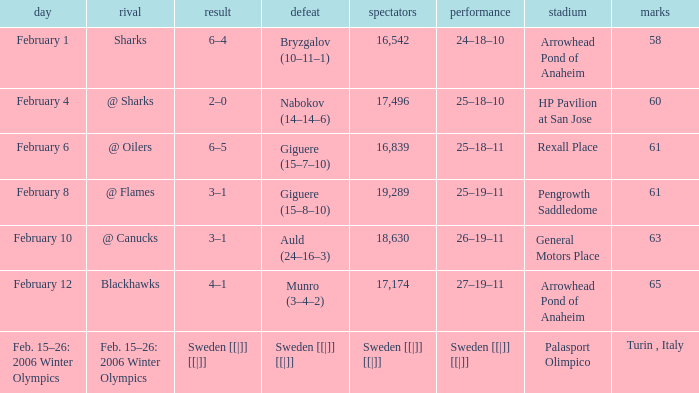What is the record at Palasport Olimpico? Sweden [[|]] [[|]]. 